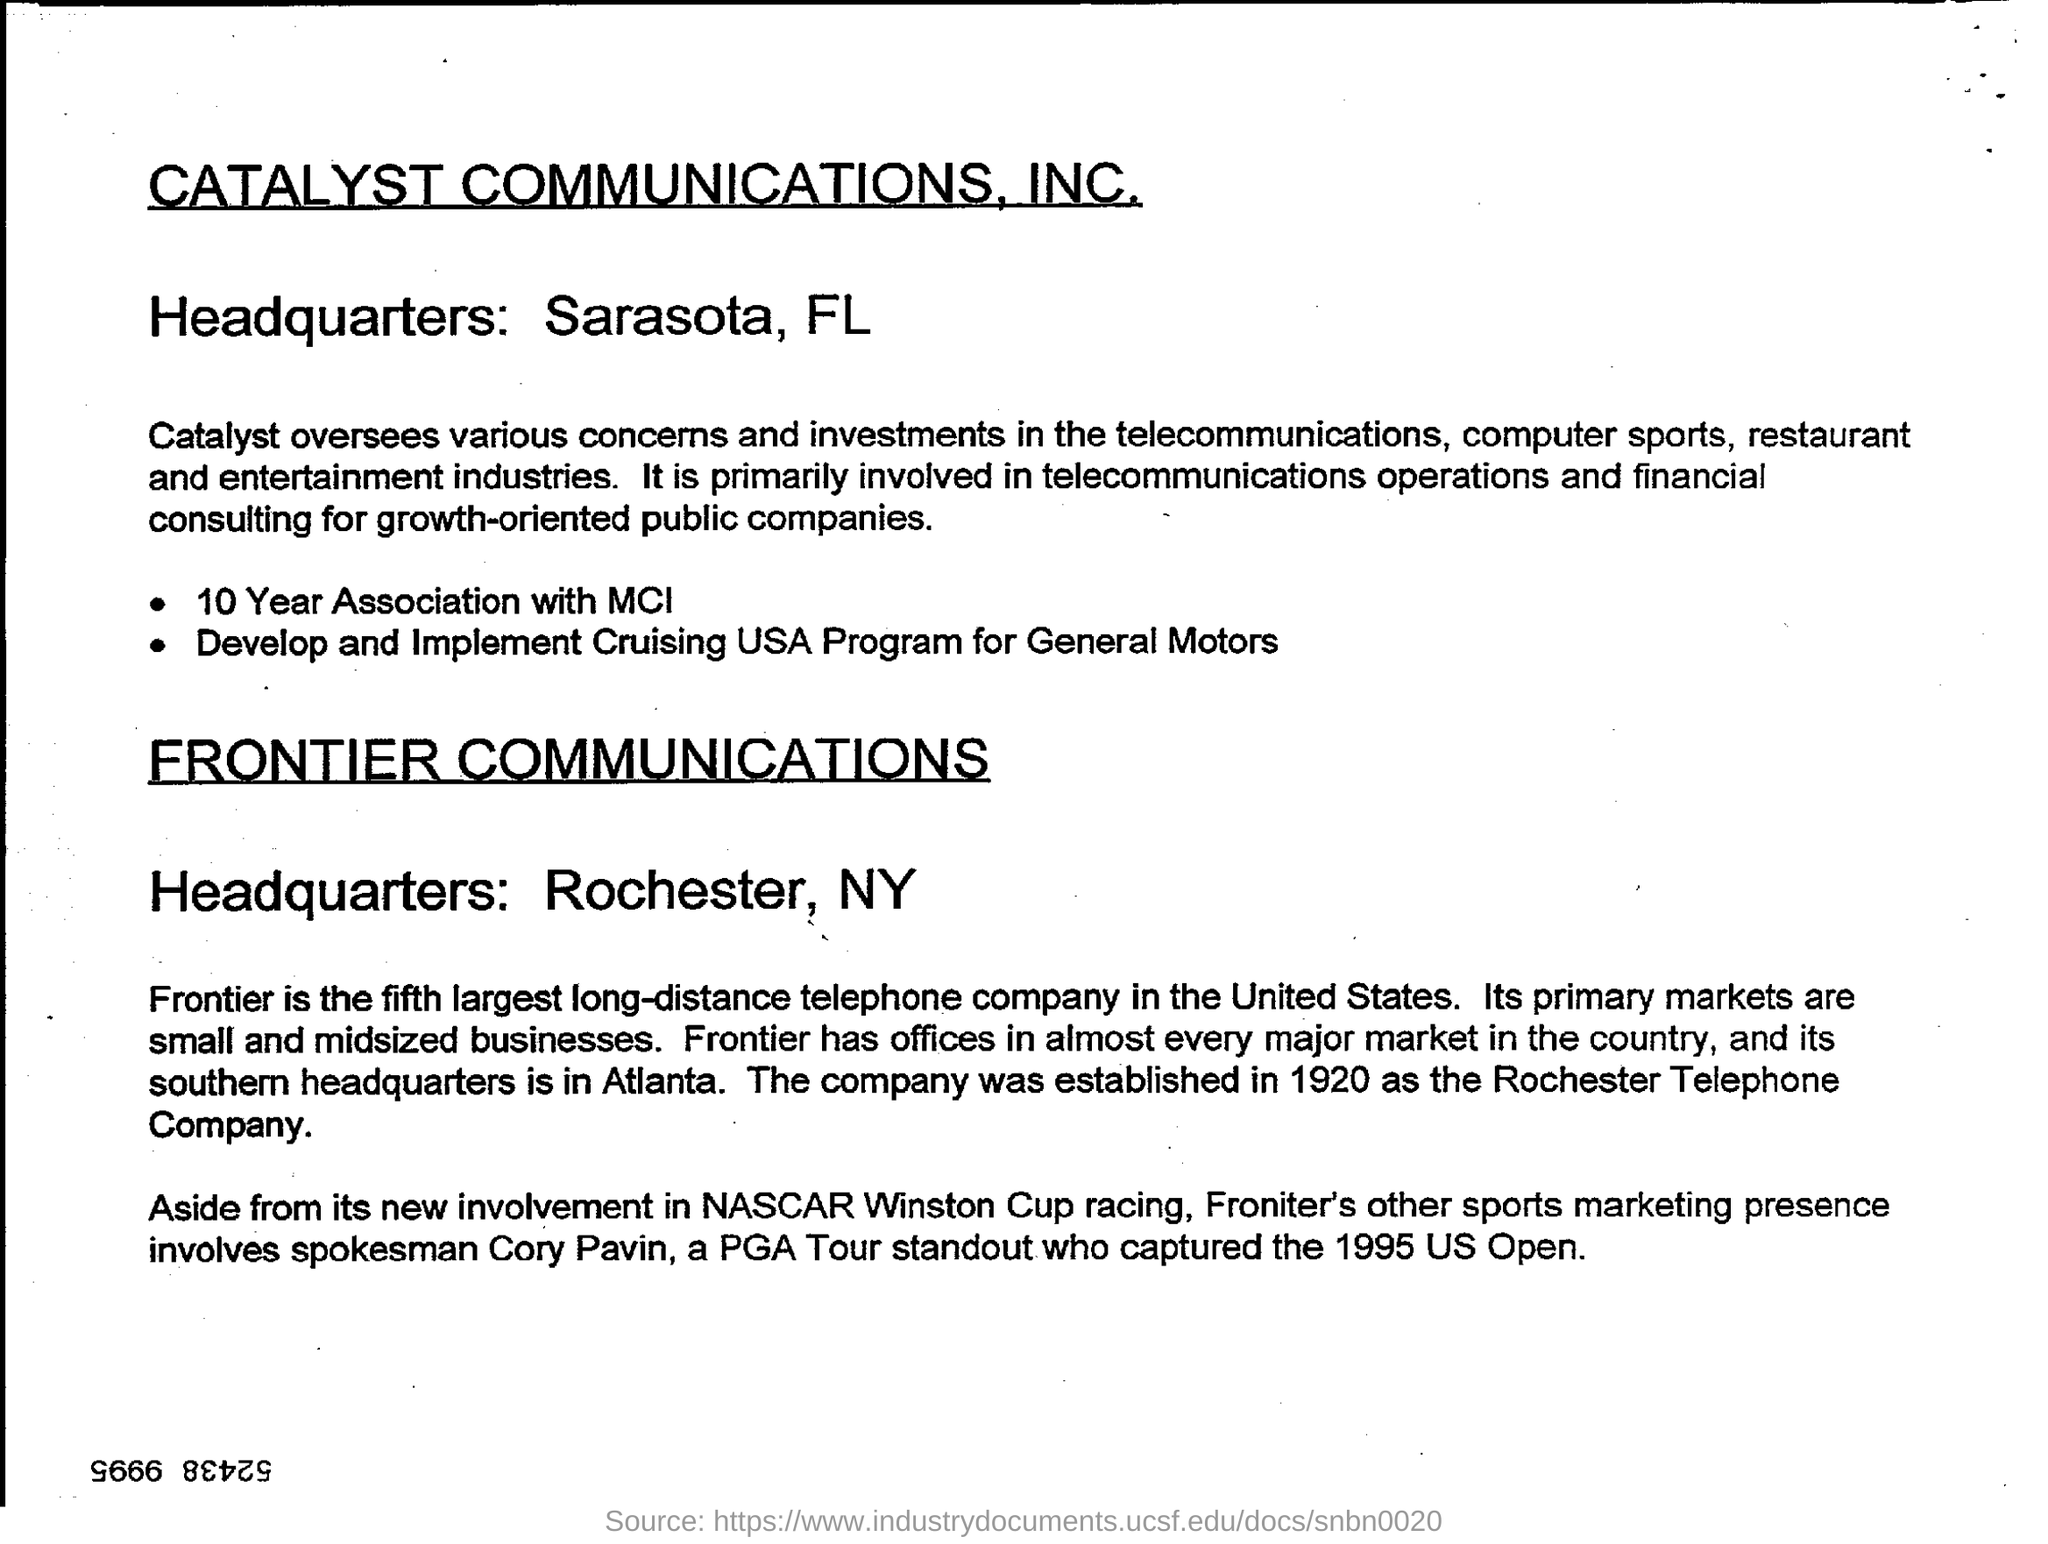Where is the headquarters for Catalyst Communications, INC?
Provide a short and direct response. Sarasota, FL. Where is the headquarters forFrontier Communications?
Offer a very short reply. Rochester, NY. 